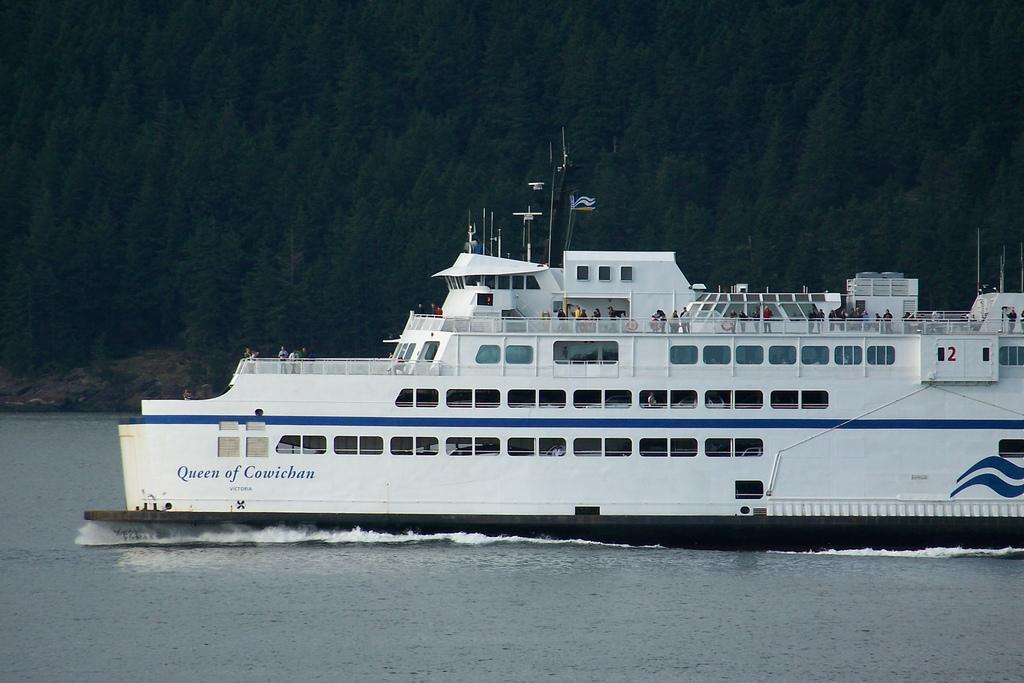What type of vehicle is in the image? There is a white color ship in the image. Where is the ship located? The ship is on the surface of water. What can be seen in the background of the image? There are trees in the background of the image. How many brothers are on the ship in the image? There is no information about brothers or any people on the ship in the image. 